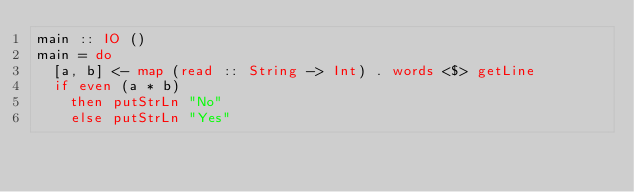Convert code to text. <code><loc_0><loc_0><loc_500><loc_500><_Haskell_>main :: IO ()                                                                                                              
main = do                                                                                                                  
  [a, b] <- map (read :: String -> Int) . words <$> getLine                                                                
  if even (a * b)                                                                                                          
    then putStrLn "No"                                                                                                     
    else putStrLn "Yes"</code> 